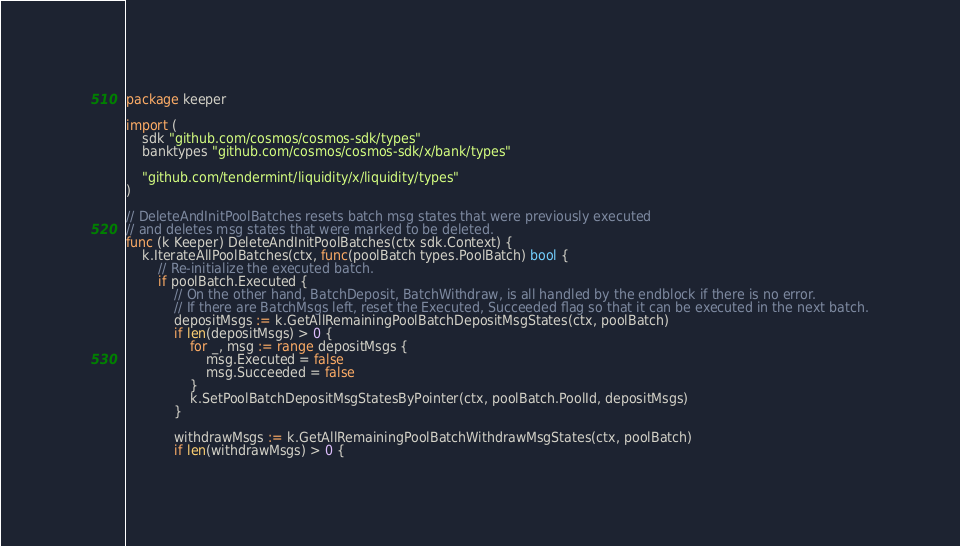<code> <loc_0><loc_0><loc_500><loc_500><_Go_>package keeper

import (
	sdk "github.com/cosmos/cosmos-sdk/types"
	banktypes "github.com/cosmos/cosmos-sdk/x/bank/types"

	"github.com/tendermint/liquidity/x/liquidity/types"
)

// DeleteAndInitPoolBatches resets batch msg states that were previously executed
// and deletes msg states that were marked to be deleted.
func (k Keeper) DeleteAndInitPoolBatches(ctx sdk.Context) {
	k.IterateAllPoolBatches(ctx, func(poolBatch types.PoolBatch) bool {
		// Re-initialize the executed batch.
		if poolBatch.Executed {
			// On the other hand, BatchDeposit, BatchWithdraw, is all handled by the endblock if there is no error.
			// If there are BatchMsgs left, reset the Executed, Succeeded flag so that it can be executed in the next batch.
			depositMsgs := k.GetAllRemainingPoolBatchDepositMsgStates(ctx, poolBatch)
			if len(depositMsgs) > 0 {
				for _, msg := range depositMsgs {
					msg.Executed = false
					msg.Succeeded = false
				}
				k.SetPoolBatchDepositMsgStatesByPointer(ctx, poolBatch.PoolId, depositMsgs)
			}

			withdrawMsgs := k.GetAllRemainingPoolBatchWithdrawMsgStates(ctx, poolBatch)
			if len(withdrawMsgs) > 0 {</code> 